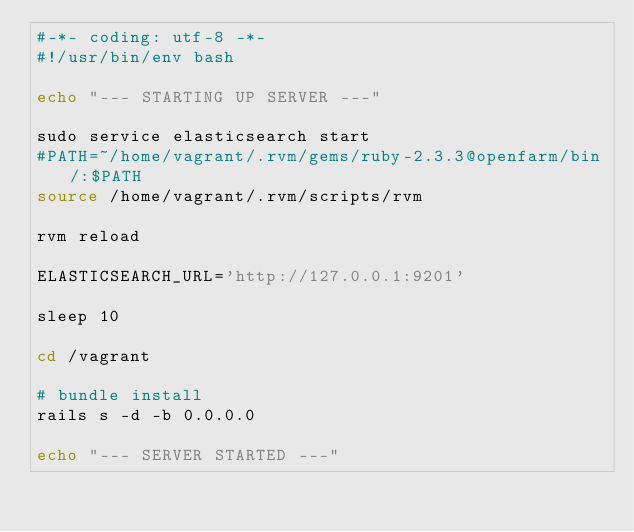Convert code to text. <code><loc_0><loc_0><loc_500><loc_500><_Bash_>#-*- coding: utf-8 -*-
#!/usr/bin/env bash

echo "--- STARTING UP SERVER ---"

sudo service elasticsearch start
#PATH=~/home/vagrant/.rvm/gems/ruby-2.3.3@openfarm/bin/:$PATH
source /home/vagrant/.rvm/scripts/rvm

rvm reload

ELASTICSEARCH_URL='http://127.0.0.1:9201'

sleep 10

cd /vagrant

# bundle install
rails s -d -b 0.0.0.0 

echo "--- SERVER STARTED ---"
</code> 